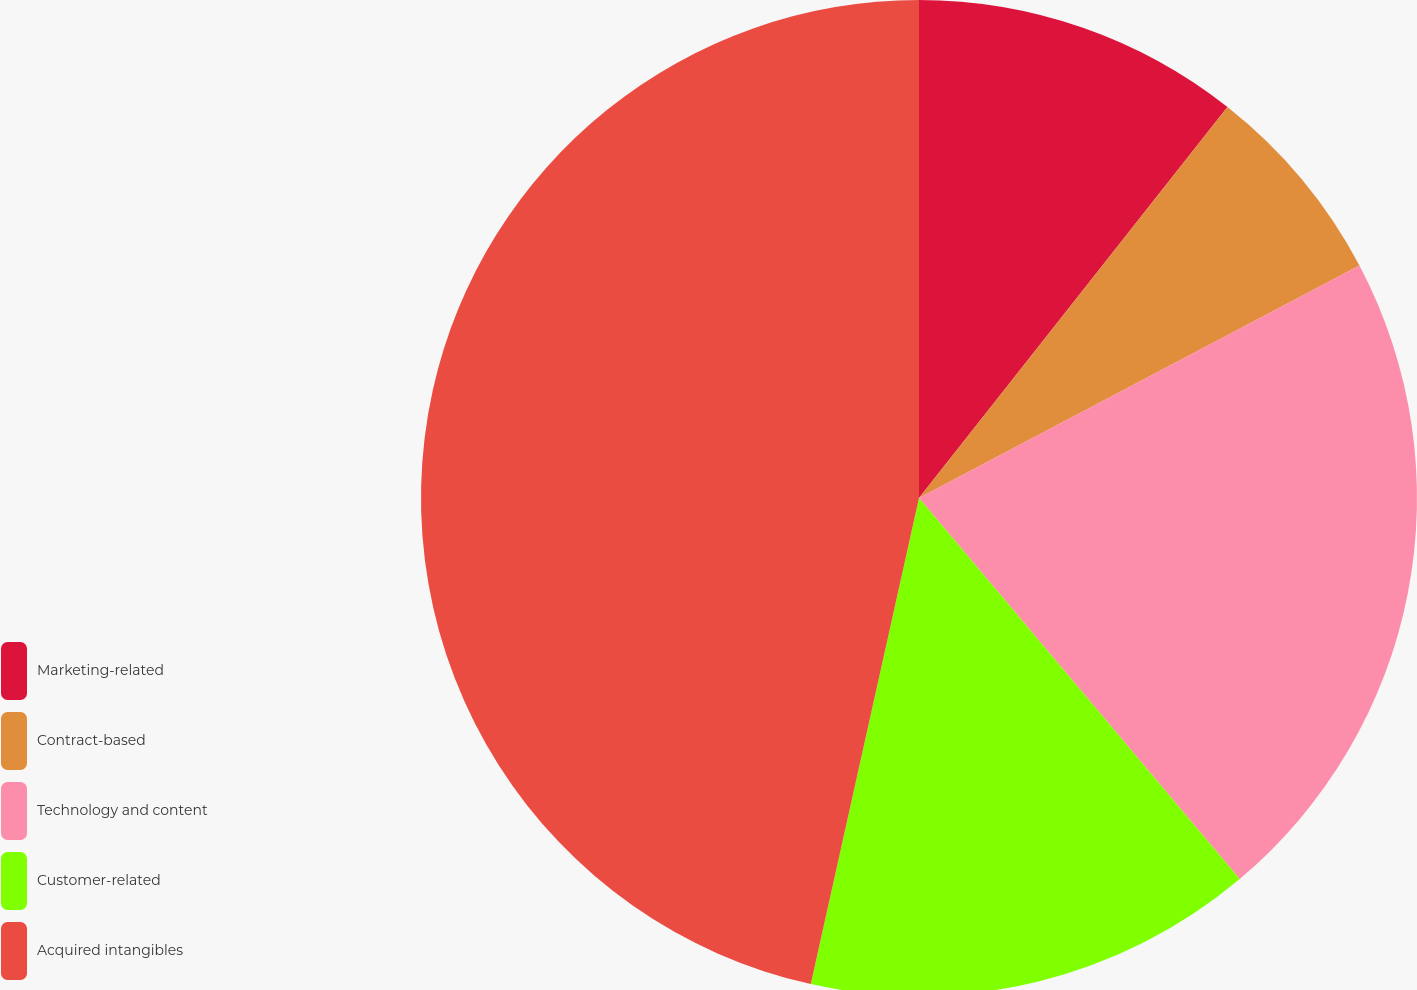Convert chart. <chart><loc_0><loc_0><loc_500><loc_500><pie_chart><fcel>Marketing-related<fcel>Contract-based<fcel>Technology and content<fcel>Customer-related<fcel>Acquired intangibles<nl><fcel>10.63%<fcel>6.64%<fcel>21.59%<fcel>14.62%<fcel>46.51%<nl></chart> 